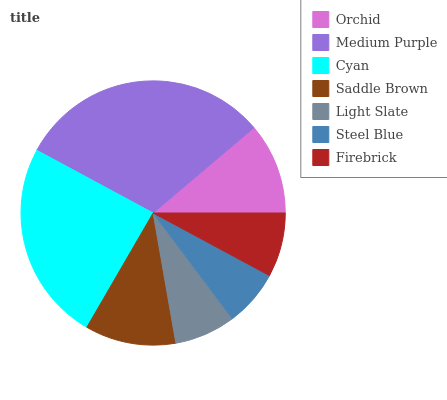Is Steel Blue the minimum?
Answer yes or no. Yes. Is Medium Purple the maximum?
Answer yes or no. Yes. Is Cyan the minimum?
Answer yes or no. No. Is Cyan the maximum?
Answer yes or no. No. Is Medium Purple greater than Cyan?
Answer yes or no. Yes. Is Cyan less than Medium Purple?
Answer yes or no. Yes. Is Cyan greater than Medium Purple?
Answer yes or no. No. Is Medium Purple less than Cyan?
Answer yes or no. No. Is Saddle Brown the high median?
Answer yes or no. Yes. Is Saddle Brown the low median?
Answer yes or no. Yes. Is Firebrick the high median?
Answer yes or no. No. Is Light Slate the low median?
Answer yes or no. No. 